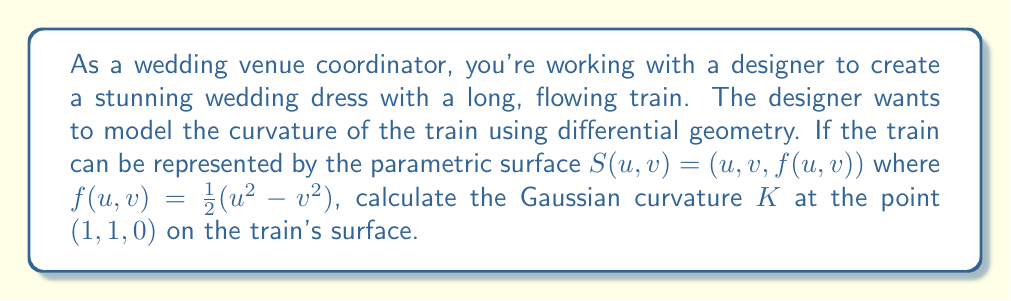Help me with this question. To calculate the Gaussian curvature $K$ at the point $(1, 1, 0)$ on the train's surface, we'll follow these steps:

1) First, we need to calculate the partial derivatives of $S(u,v)$:

   $S_u = (1, 0, f_u)$ where $f_u = u$
   $S_v = (0, 1, f_v)$ where $f_v = -v$

2) Now, we calculate the coefficients of the first fundamental form:

   $E = S_u \cdot S_u = 1^2 + 0^2 + u^2 = 1 + u^2$
   $F = S_u \cdot S_v = 0$
   $G = S_v \cdot S_v = 0^2 + 1^2 + v^2 = 1 + v^2$

3) Next, we calculate the second partial derivatives:

   $S_{uu} = (0, 0, 1)$
   $S_{uv} = S_{vu} = (0, 0, 0)$
   $S_{vv} = (0, 0, -1)$

4) We can now calculate the coefficients of the second fundamental form:

   $L = S_{uu} \cdot N = \frac{1}{\sqrt{1 + u^2 + v^2}}$
   $M = S_{uv} \cdot N = 0$
   $N = S_{vv} \cdot N = -\frac{1}{\sqrt{1 + u^2 + v^2}}$

   Where $N$ is the unit normal vector: $N = \frac{S_u \times S_v}{|S_u \times S_v|} = \frac{(-u, -v, 1)}{\sqrt{1 + u^2 + v^2}}$

5) The Gaussian curvature $K$ is given by:

   $K = \frac{LN - M^2}{EG - F^2}$

6) Substituting our values at the point $(1, 1, 0)$:

   $K = \frac{(\frac{1}{\sqrt{3}})(-\frac{1}{\sqrt{3}}) - 0^2}{(2)(2) - 0^2} = \frac{-\frac{1}{3}}{4} = -\frac{1}{12}$

Therefore, the Gaussian curvature $K$ at the point $(1, 1, 0)$ on the train's surface is $-\frac{1}{12}$.
Answer: $K = -\frac{1}{12}$ 